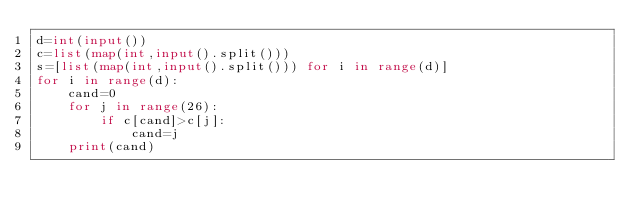<code> <loc_0><loc_0><loc_500><loc_500><_Python_>d=int(input())
c=list(map(int,input().split()))
s=[list(map(int,input().split())) for i in range(d)]
for i in range(d):
    cand=0
    for j in range(26):
        if c[cand]>c[j]:
            cand=j
    print(cand)</code> 